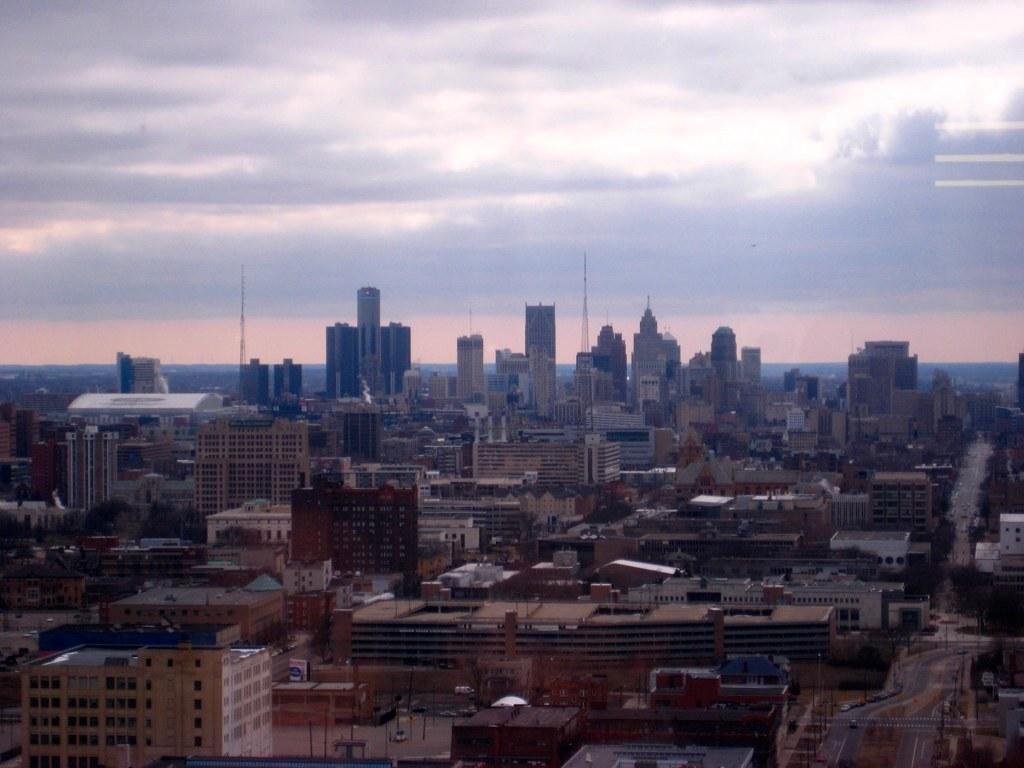How would you summarize this image in a sentence or two? In this image we can see buildings, trees, roads, current polls, vehicles. In the background there is a sky and clouds. 